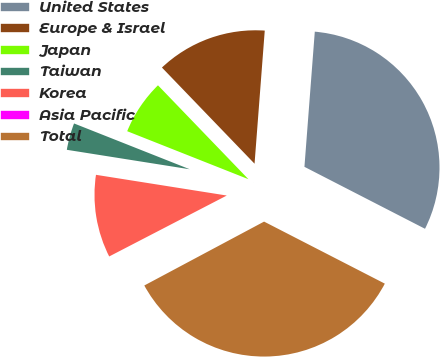Convert chart to OTSL. <chart><loc_0><loc_0><loc_500><loc_500><pie_chart><fcel>United States<fcel>Europe & Israel<fcel>Japan<fcel>Taiwan<fcel>Korea<fcel>Asia Pacific<fcel>Total<nl><fcel>31.34%<fcel>13.42%<fcel>6.8%<fcel>3.5%<fcel>10.11%<fcel>0.19%<fcel>34.65%<nl></chart> 